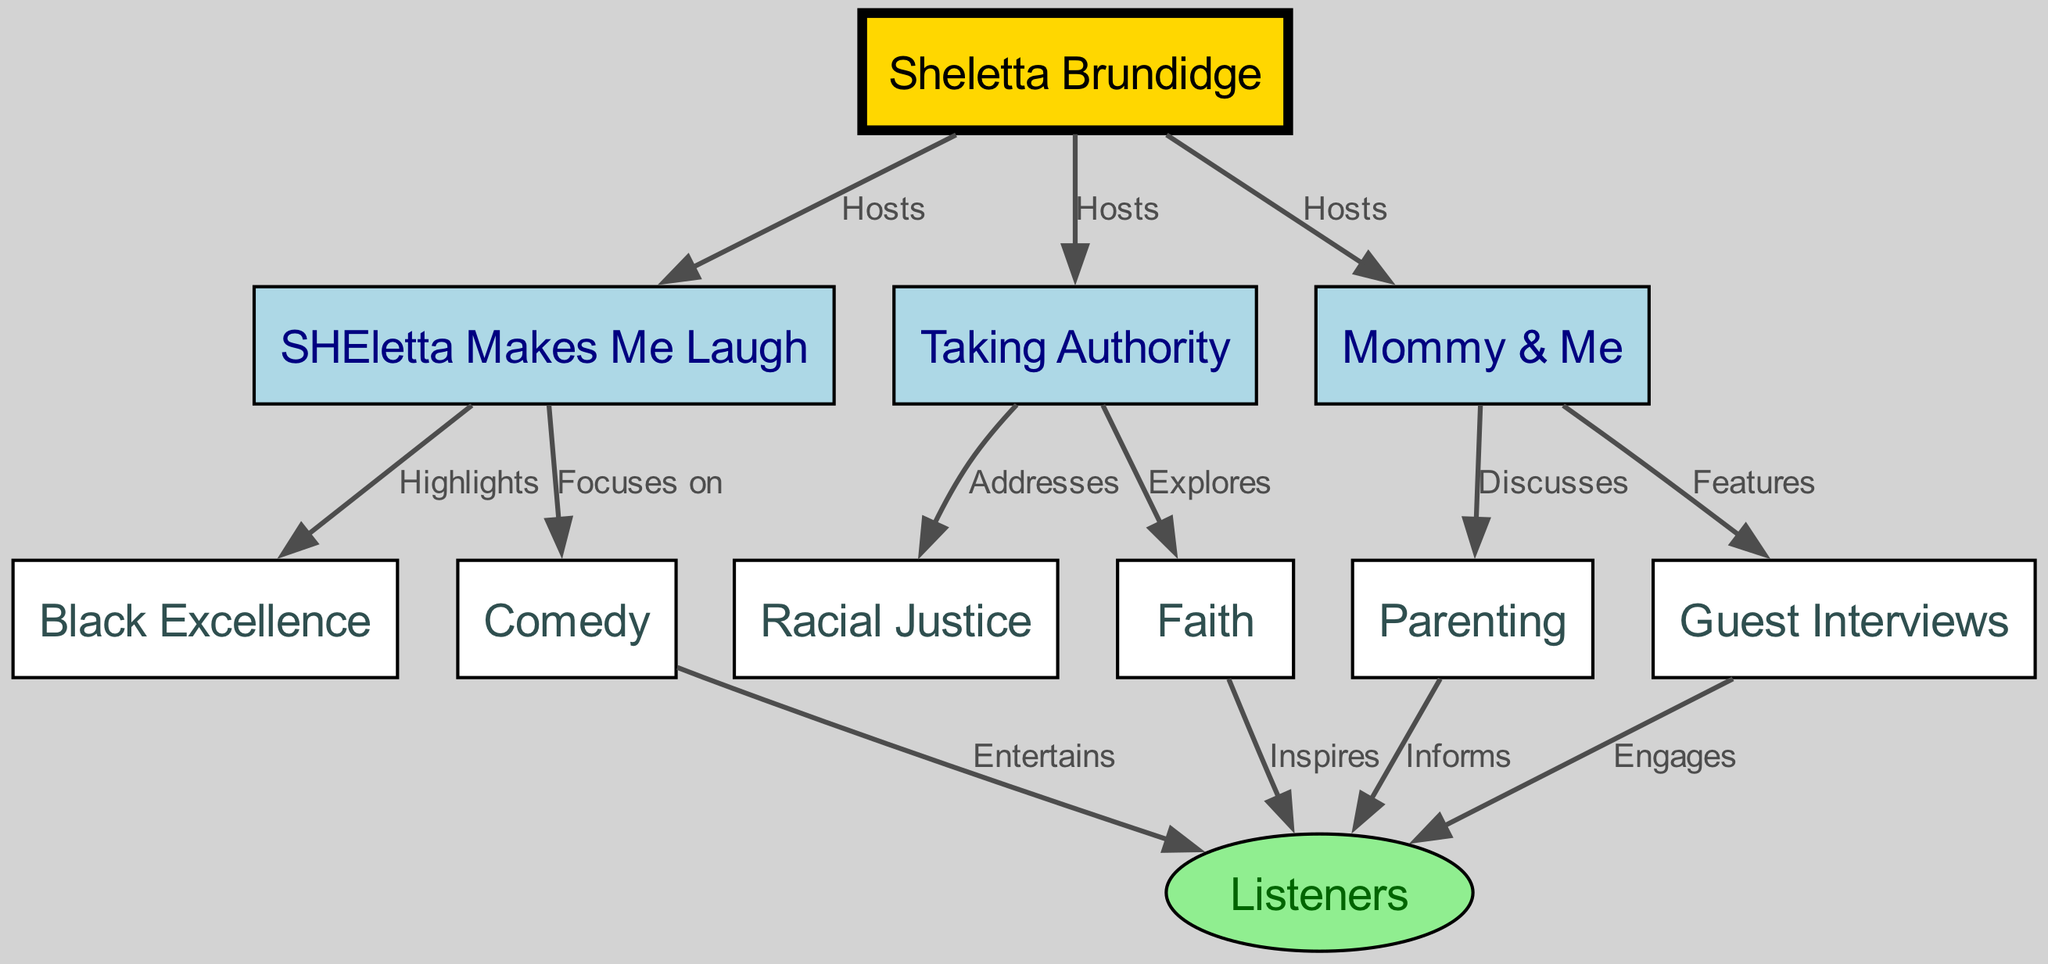What is the total number of nodes in the diagram? The diagram includes nodes for both hosts and content categories. By counting each unique node listed, we find there are 11 nodes total.
Answer: 11 What type of content does "SHEletta Makes Me Laugh" focus on? According to the directed edge, "SHEletta Makes Me Laugh" focuses on "Comedy." This is explicitly indicated by the relationship labeled in the diagram.
Answer: Comedy Who hosts the podcast "Mommy & Me"? The diagram shows that "Mommy & Me" is hosted by "Sheletta Brundidge." This relationship is directly indicated as labeled in the edges section of the diagram.
Answer: Sheletta Brundidge Which podcast addresses the topic of "Racial Justice"? The edge from "Taking Authority" shows that this podcast addresses the topic of "Racial Justice," as indicated by the labeled relationship connecting both nodes.
Answer: Taking Authority How many topics are parents informed about through "Mommy & Me"? The diagram indicates that "Mommy & Me" informs "Listeners" about "Parenting." This is the only topic that derives from "Mommy & Me" as represented in the edges.
Answer: 1 Which node is the primary host for all podcasts? The starting node of the directed graph is "Sheletta Brundidge," which has directed edges to all podcast titles she hosts, making her the primary host.
Answer: Sheletta Brundidge What is the output node for "Guest Interviews"? The directed edge from "Guest Interviews" leads to the node "Listeners," indicating that the output of "Guest Interviews" engages the listeners as shown in the diagram.
Answer: Listeners Which podcast highlights "Black Excellence"? The direct connection in the diagram shows that "SHEletta Makes Me Laugh" highlights "Black Excellence." This relationship is labeled clearly in the edge connecting these two nodes.
Answer: SHEletta Makes Me Laugh Which two nodes are connected through the label "Explores"? The edge labeled "Explores" connects "Taking Authority" to "Faith." This indicates that the exploring relationship is clearly defined by this directed connection.
Answer: Taking Authority, Faith 